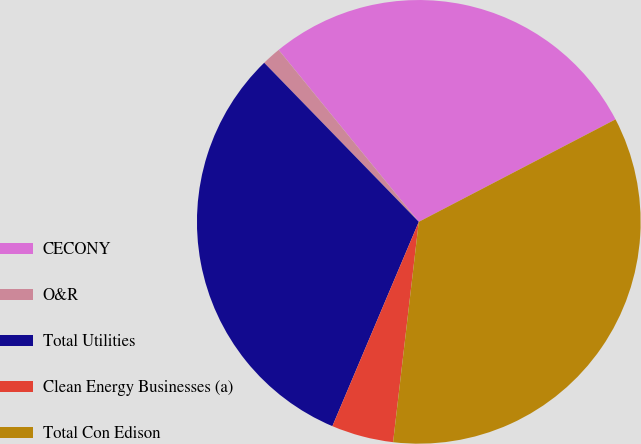<chart> <loc_0><loc_0><loc_500><loc_500><pie_chart><fcel>CECONY<fcel>O&R<fcel>Total Utilities<fcel>Clean Energy Businesses (a)<fcel>Total Con Edison<nl><fcel>28.24%<fcel>1.39%<fcel>31.36%<fcel>4.52%<fcel>34.49%<nl></chart> 